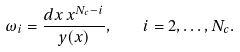Convert formula to latex. <formula><loc_0><loc_0><loc_500><loc_500>\omega _ { i } = \frac { d x \, x ^ { N _ { c } - i } } { y ( x ) } , \quad i = 2 , \dots , N _ { c } .</formula> 